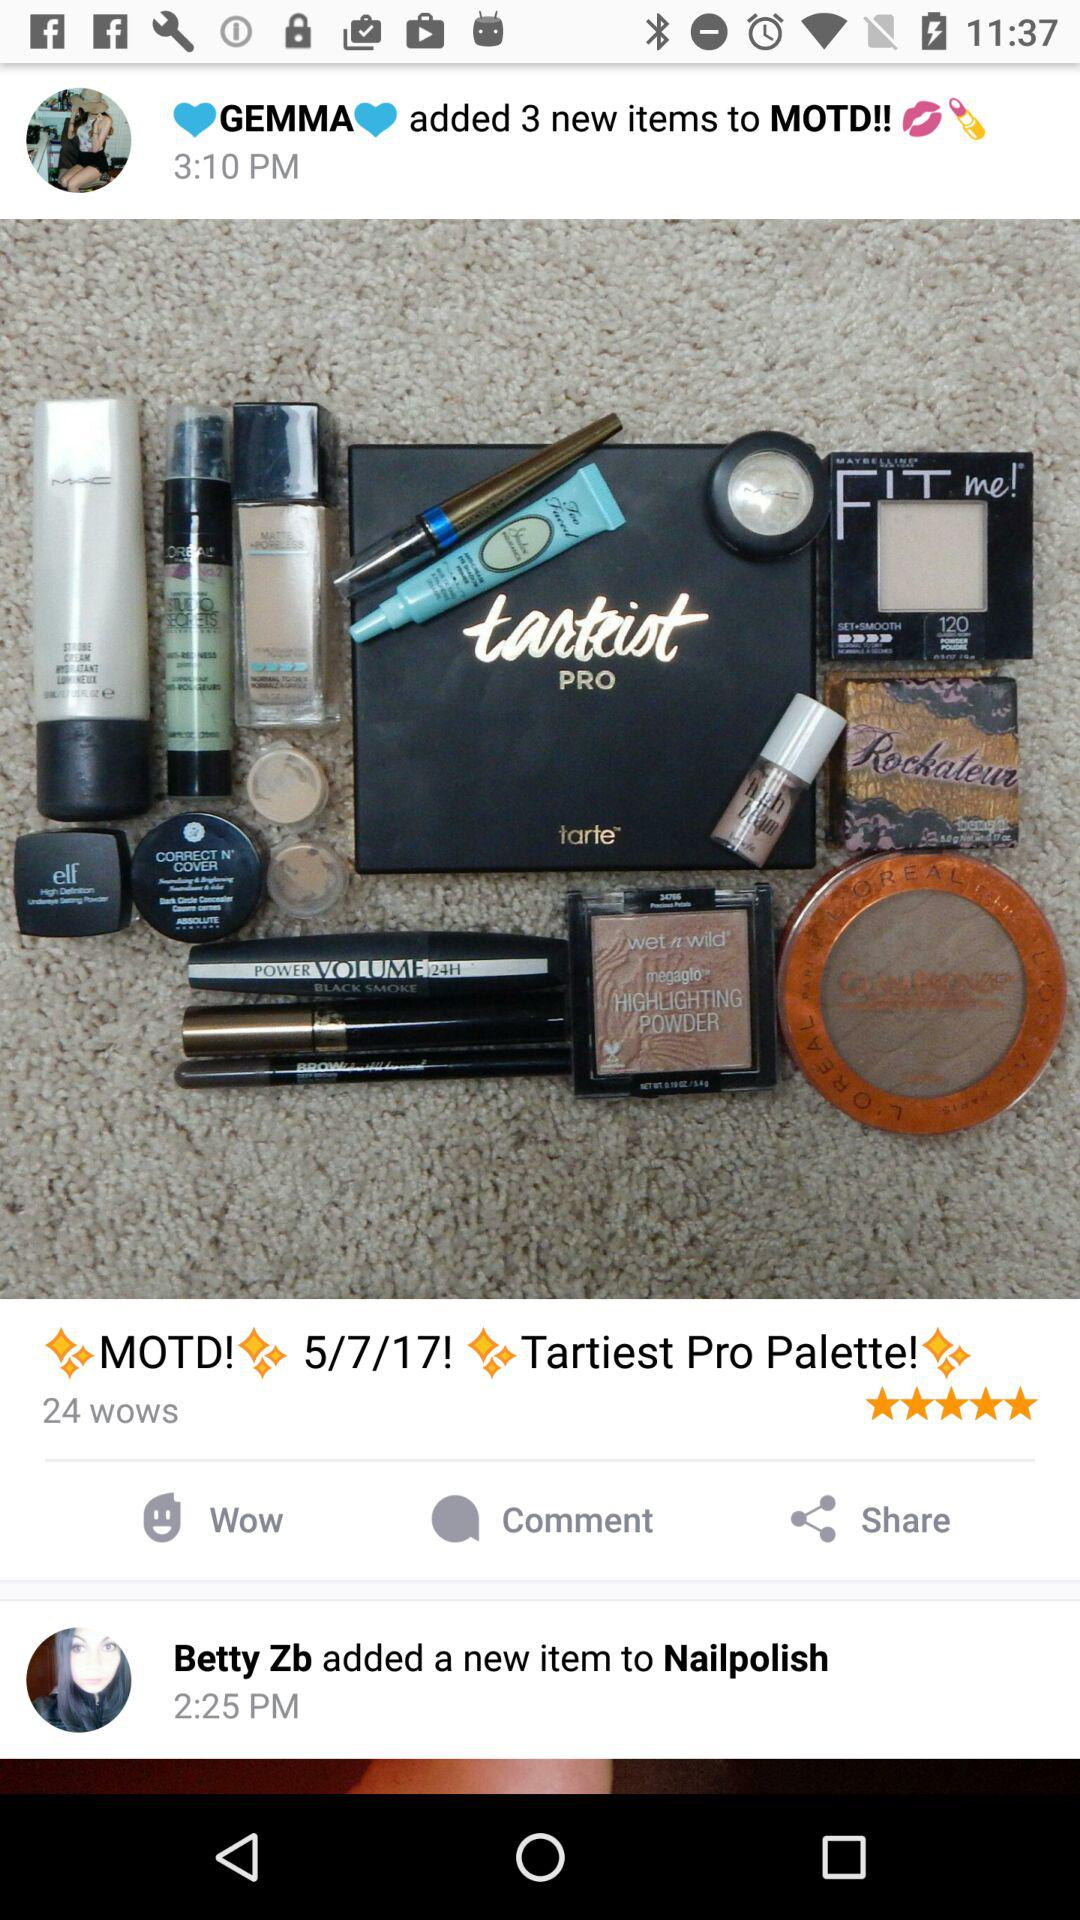At what time did Betty Zb post? Betty Zb posted at 12:25 PM. 